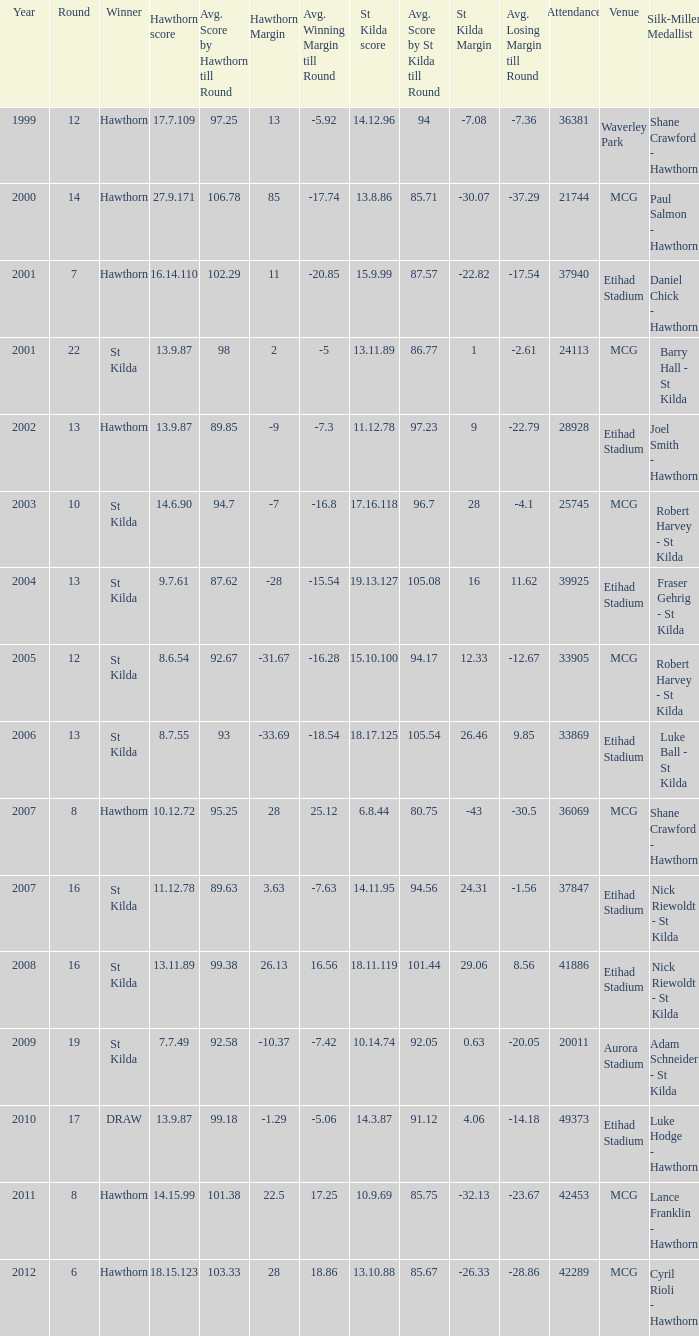How many winners have st kilda score at 14.11.95? 1.0. 